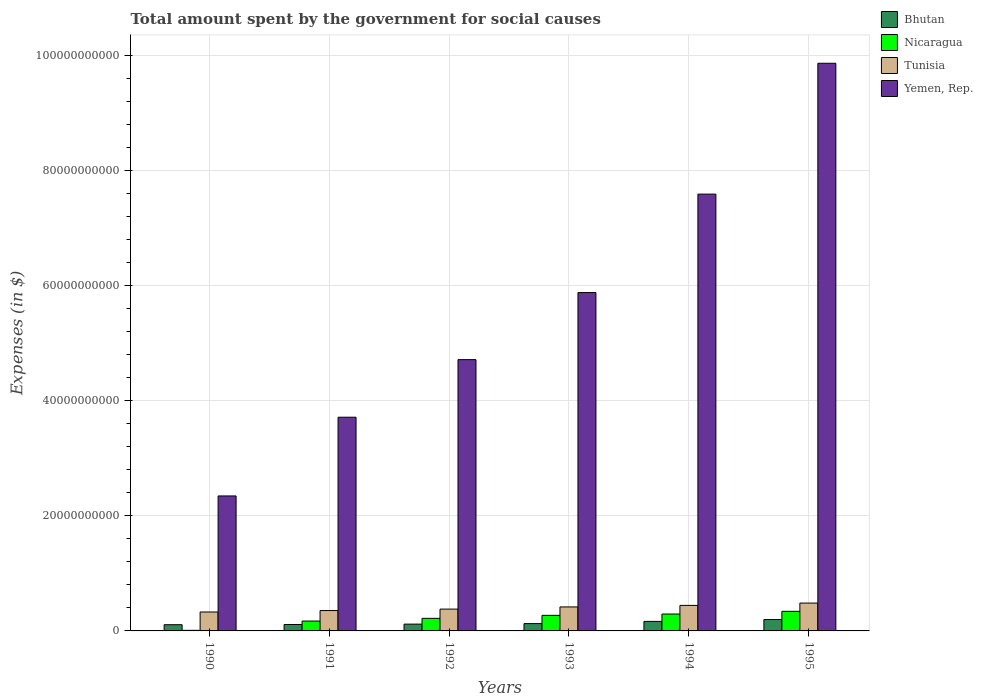How many different coloured bars are there?
Provide a short and direct response. 4. How many bars are there on the 6th tick from the left?
Offer a very short reply. 4. How many bars are there on the 5th tick from the right?
Offer a terse response. 4. What is the label of the 6th group of bars from the left?
Your answer should be compact. 1995. What is the amount spent for social causes by the government in Tunisia in 1995?
Provide a succinct answer. 4.84e+09. Across all years, what is the maximum amount spent for social causes by the government in Bhutan?
Offer a very short reply. 1.98e+09. Across all years, what is the minimum amount spent for social causes by the government in Nicaragua?
Offer a very short reply. 1.02e+08. In which year was the amount spent for social causes by the government in Nicaragua maximum?
Offer a terse response. 1995. What is the total amount spent for social causes by the government in Tunisia in the graph?
Provide a short and direct response. 2.41e+1. What is the difference between the amount spent for social causes by the government in Tunisia in 1993 and that in 1994?
Offer a very short reply. -2.65e+08. What is the difference between the amount spent for social causes by the government in Tunisia in 1995 and the amount spent for social causes by the government in Yemen, Rep. in 1990?
Keep it short and to the point. -1.86e+1. What is the average amount spent for social causes by the government in Tunisia per year?
Ensure brevity in your answer.  4.01e+09. In the year 1995, what is the difference between the amount spent for social causes by the government in Yemen, Rep. and amount spent for social causes by the government in Tunisia?
Your answer should be very brief. 9.38e+1. In how many years, is the amount spent for social causes by the government in Bhutan greater than 36000000000 $?
Make the answer very short. 0. What is the ratio of the amount spent for social causes by the government in Yemen, Rep. in 1992 to that in 1995?
Offer a very short reply. 0.48. Is the amount spent for social causes by the government in Nicaragua in 1992 less than that in 1994?
Keep it short and to the point. Yes. Is the difference between the amount spent for social causes by the government in Yemen, Rep. in 1993 and 1995 greater than the difference between the amount spent for social causes by the government in Tunisia in 1993 and 1995?
Provide a succinct answer. No. What is the difference between the highest and the second highest amount spent for social causes by the government in Bhutan?
Keep it short and to the point. 3.28e+08. What is the difference between the highest and the lowest amount spent for social causes by the government in Bhutan?
Give a very brief answer. 9.02e+08. Is the sum of the amount spent for social causes by the government in Yemen, Rep. in 1991 and 1994 greater than the maximum amount spent for social causes by the government in Nicaragua across all years?
Offer a terse response. Yes. Is it the case that in every year, the sum of the amount spent for social causes by the government in Nicaragua and amount spent for social causes by the government in Tunisia is greater than the sum of amount spent for social causes by the government in Bhutan and amount spent for social causes by the government in Yemen, Rep.?
Provide a short and direct response. No. What does the 1st bar from the left in 1991 represents?
Provide a succinct answer. Bhutan. What does the 3rd bar from the right in 1990 represents?
Offer a very short reply. Nicaragua. Does the graph contain any zero values?
Give a very brief answer. No. Where does the legend appear in the graph?
Ensure brevity in your answer.  Top right. How many legend labels are there?
Offer a very short reply. 4. How are the legend labels stacked?
Provide a succinct answer. Vertical. What is the title of the graph?
Your response must be concise. Total amount spent by the government for social causes. What is the label or title of the X-axis?
Offer a very short reply. Years. What is the label or title of the Y-axis?
Offer a very short reply. Expenses (in $). What is the Expenses (in $) in Bhutan in 1990?
Offer a terse response. 1.08e+09. What is the Expenses (in $) of Nicaragua in 1990?
Ensure brevity in your answer.  1.02e+08. What is the Expenses (in $) of Tunisia in 1990?
Your answer should be compact. 3.29e+09. What is the Expenses (in $) in Yemen, Rep. in 1990?
Offer a terse response. 2.35e+1. What is the Expenses (in $) in Bhutan in 1991?
Your answer should be very brief. 1.12e+09. What is the Expenses (in $) in Nicaragua in 1991?
Give a very brief answer. 1.71e+09. What is the Expenses (in $) of Tunisia in 1991?
Give a very brief answer. 3.54e+09. What is the Expenses (in $) in Yemen, Rep. in 1991?
Your answer should be very brief. 3.71e+1. What is the Expenses (in $) in Bhutan in 1992?
Provide a succinct answer. 1.18e+09. What is the Expenses (in $) of Nicaragua in 1992?
Provide a succinct answer. 2.19e+09. What is the Expenses (in $) of Tunisia in 1992?
Offer a very short reply. 3.79e+09. What is the Expenses (in $) of Yemen, Rep. in 1992?
Make the answer very short. 4.71e+1. What is the Expenses (in $) in Bhutan in 1993?
Give a very brief answer. 1.27e+09. What is the Expenses (in $) in Nicaragua in 1993?
Your answer should be compact. 2.71e+09. What is the Expenses (in $) in Tunisia in 1993?
Offer a very short reply. 4.17e+09. What is the Expenses (in $) in Yemen, Rep. in 1993?
Provide a succinct answer. 5.88e+1. What is the Expenses (in $) in Bhutan in 1994?
Your answer should be very brief. 1.65e+09. What is the Expenses (in $) in Nicaragua in 1994?
Give a very brief answer. 2.94e+09. What is the Expenses (in $) in Tunisia in 1994?
Give a very brief answer. 4.43e+09. What is the Expenses (in $) of Yemen, Rep. in 1994?
Offer a very short reply. 7.59e+1. What is the Expenses (in $) in Bhutan in 1995?
Give a very brief answer. 1.98e+09. What is the Expenses (in $) in Nicaragua in 1995?
Make the answer very short. 3.41e+09. What is the Expenses (in $) in Tunisia in 1995?
Your answer should be very brief. 4.84e+09. What is the Expenses (in $) of Yemen, Rep. in 1995?
Provide a succinct answer. 9.86e+1. Across all years, what is the maximum Expenses (in $) in Bhutan?
Make the answer very short. 1.98e+09. Across all years, what is the maximum Expenses (in $) in Nicaragua?
Keep it short and to the point. 3.41e+09. Across all years, what is the maximum Expenses (in $) in Tunisia?
Your answer should be very brief. 4.84e+09. Across all years, what is the maximum Expenses (in $) of Yemen, Rep.?
Your response must be concise. 9.86e+1. Across all years, what is the minimum Expenses (in $) of Bhutan?
Your answer should be compact. 1.08e+09. Across all years, what is the minimum Expenses (in $) of Nicaragua?
Keep it short and to the point. 1.02e+08. Across all years, what is the minimum Expenses (in $) in Tunisia?
Make the answer very short. 3.29e+09. Across all years, what is the minimum Expenses (in $) in Yemen, Rep.?
Provide a succinct answer. 2.35e+1. What is the total Expenses (in $) of Bhutan in the graph?
Provide a short and direct response. 8.29e+09. What is the total Expenses (in $) in Nicaragua in the graph?
Provide a short and direct response. 1.31e+1. What is the total Expenses (in $) in Tunisia in the graph?
Ensure brevity in your answer.  2.41e+1. What is the total Expenses (in $) of Yemen, Rep. in the graph?
Provide a succinct answer. 3.41e+11. What is the difference between the Expenses (in $) of Bhutan in 1990 and that in 1991?
Your response must be concise. -3.82e+07. What is the difference between the Expenses (in $) in Nicaragua in 1990 and that in 1991?
Your answer should be very brief. -1.61e+09. What is the difference between the Expenses (in $) of Tunisia in 1990 and that in 1991?
Make the answer very short. -2.52e+08. What is the difference between the Expenses (in $) of Yemen, Rep. in 1990 and that in 1991?
Ensure brevity in your answer.  -1.37e+1. What is the difference between the Expenses (in $) of Bhutan in 1990 and that in 1992?
Offer a terse response. -1.04e+08. What is the difference between the Expenses (in $) in Nicaragua in 1990 and that in 1992?
Your response must be concise. -2.09e+09. What is the difference between the Expenses (in $) in Tunisia in 1990 and that in 1992?
Your response must be concise. -5.01e+08. What is the difference between the Expenses (in $) of Yemen, Rep. in 1990 and that in 1992?
Provide a succinct answer. -2.37e+1. What is the difference between the Expenses (in $) of Bhutan in 1990 and that in 1993?
Make the answer very short. -1.93e+08. What is the difference between the Expenses (in $) of Nicaragua in 1990 and that in 1993?
Provide a succinct answer. -2.60e+09. What is the difference between the Expenses (in $) in Tunisia in 1990 and that in 1993?
Ensure brevity in your answer.  -8.80e+08. What is the difference between the Expenses (in $) in Yemen, Rep. in 1990 and that in 1993?
Ensure brevity in your answer.  -3.53e+1. What is the difference between the Expenses (in $) in Bhutan in 1990 and that in 1994?
Provide a succinct answer. -5.74e+08. What is the difference between the Expenses (in $) in Nicaragua in 1990 and that in 1994?
Give a very brief answer. -2.83e+09. What is the difference between the Expenses (in $) in Tunisia in 1990 and that in 1994?
Your response must be concise. -1.15e+09. What is the difference between the Expenses (in $) in Yemen, Rep. in 1990 and that in 1994?
Keep it short and to the point. -5.24e+1. What is the difference between the Expenses (in $) in Bhutan in 1990 and that in 1995?
Ensure brevity in your answer.  -9.02e+08. What is the difference between the Expenses (in $) of Nicaragua in 1990 and that in 1995?
Give a very brief answer. -3.30e+09. What is the difference between the Expenses (in $) of Tunisia in 1990 and that in 1995?
Provide a succinct answer. -1.55e+09. What is the difference between the Expenses (in $) of Yemen, Rep. in 1990 and that in 1995?
Offer a terse response. -7.52e+1. What is the difference between the Expenses (in $) of Bhutan in 1991 and that in 1992?
Offer a very short reply. -6.56e+07. What is the difference between the Expenses (in $) in Nicaragua in 1991 and that in 1992?
Your answer should be compact. -4.74e+08. What is the difference between the Expenses (in $) of Tunisia in 1991 and that in 1992?
Give a very brief answer. -2.49e+08. What is the difference between the Expenses (in $) in Yemen, Rep. in 1991 and that in 1992?
Ensure brevity in your answer.  -1.00e+1. What is the difference between the Expenses (in $) of Bhutan in 1991 and that in 1993?
Provide a short and direct response. -1.55e+08. What is the difference between the Expenses (in $) of Nicaragua in 1991 and that in 1993?
Make the answer very short. -9.92e+08. What is the difference between the Expenses (in $) in Tunisia in 1991 and that in 1993?
Offer a terse response. -6.28e+08. What is the difference between the Expenses (in $) in Yemen, Rep. in 1991 and that in 1993?
Make the answer very short. -2.17e+1. What is the difference between the Expenses (in $) in Bhutan in 1991 and that in 1994?
Provide a short and direct response. -5.36e+08. What is the difference between the Expenses (in $) of Nicaragua in 1991 and that in 1994?
Provide a succinct answer. -1.22e+09. What is the difference between the Expenses (in $) in Tunisia in 1991 and that in 1994?
Your response must be concise. -8.93e+08. What is the difference between the Expenses (in $) of Yemen, Rep. in 1991 and that in 1994?
Your answer should be very brief. -3.88e+1. What is the difference between the Expenses (in $) in Bhutan in 1991 and that in 1995?
Make the answer very short. -8.64e+08. What is the difference between the Expenses (in $) in Nicaragua in 1991 and that in 1995?
Give a very brief answer. -1.69e+09. What is the difference between the Expenses (in $) of Tunisia in 1991 and that in 1995?
Give a very brief answer. -1.30e+09. What is the difference between the Expenses (in $) in Yemen, Rep. in 1991 and that in 1995?
Offer a terse response. -6.15e+1. What is the difference between the Expenses (in $) of Bhutan in 1992 and that in 1993?
Give a very brief answer. -8.91e+07. What is the difference between the Expenses (in $) of Nicaragua in 1992 and that in 1993?
Offer a terse response. -5.19e+08. What is the difference between the Expenses (in $) in Tunisia in 1992 and that in 1993?
Provide a succinct answer. -3.79e+08. What is the difference between the Expenses (in $) of Yemen, Rep. in 1992 and that in 1993?
Ensure brevity in your answer.  -1.17e+1. What is the difference between the Expenses (in $) of Bhutan in 1992 and that in 1994?
Provide a succinct answer. -4.71e+08. What is the difference between the Expenses (in $) of Nicaragua in 1992 and that in 1994?
Give a very brief answer. -7.49e+08. What is the difference between the Expenses (in $) of Tunisia in 1992 and that in 1994?
Provide a succinct answer. -6.44e+08. What is the difference between the Expenses (in $) in Yemen, Rep. in 1992 and that in 1994?
Make the answer very short. -2.88e+1. What is the difference between the Expenses (in $) in Bhutan in 1992 and that in 1995?
Give a very brief answer. -7.98e+08. What is the difference between the Expenses (in $) in Nicaragua in 1992 and that in 1995?
Offer a very short reply. -1.22e+09. What is the difference between the Expenses (in $) in Tunisia in 1992 and that in 1995?
Your answer should be very brief. -1.05e+09. What is the difference between the Expenses (in $) of Yemen, Rep. in 1992 and that in 1995?
Offer a terse response. -5.15e+1. What is the difference between the Expenses (in $) in Bhutan in 1993 and that in 1994?
Give a very brief answer. -3.82e+08. What is the difference between the Expenses (in $) in Nicaragua in 1993 and that in 1994?
Provide a short and direct response. -2.30e+08. What is the difference between the Expenses (in $) in Tunisia in 1993 and that in 1994?
Ensure brevity in your answer.  -2.65e+08. What is the difference between the Expenses (in $) in Yemen, Rep. in 1993 and that in 1994?
Offer a very short reply. -1.71e+1. What is the difference between the Expenses (in $) in Bhutan in 1993 and that in 1995?
Your answer should be very brief. -7.09e+08. What is the difference between the Expenses (in $) in Nicaragua in 1993 and that in 1995?
Make the answer very short. -6.99e+08. What is the difference between the Expenses (in $) in Tunisia in 1993 and that in 1995?
Give a very brief answer. -6.69e+08. What is the difference between the Expenses (in $) of Yemen, Rep. in 1993 and that in 1995?
Your response must be concise. -3.98e+1. What is the difference between the Expenses (in $) of Bhutan in 1994 and that in 1995?
Provide a succinct answer. -3.28e+08. What is the difference between the Expenses (in $) in Nicaragua in 1994 and that in 1995?
Provide a short and direct response. -4.69e+08. What is the difference between the Expenses (in $) of Tunisia in 1994 and that in 1995?
Provide a succinct answer. -4.04e+08. What is the difference between the Expenses (in $) of Yemen, Rep. in 1994 and that in 1995?
Offer a terse response. -2.27e+1. What is the difference between the Expenses (in $) in Bhutan in 1990 and the Expenses (in $) in Nicaragua in 1991?
Give a very brief answer. -6.34e+08. What is the difference between the Expenses (in $) of Bhutan in 1990 and the Expenses (in $) of Tunisia in 1991?
Your answer should be compact. -2.46e+09. What is the difference between the Expenses (in $) of Bhutan in 1990 and the Expenses (in $) of Yemen, Rep. in 1991?
Ensure brevity in your answer.  -3.61e+1. What is the difference between the Expenses (in $) in Nicaragua in 1990 and the Expenses (in $) in Tunisia in 1991?
Ensure brevity in your answer.  -3.44e+09. What is the difference between the Expenses (in $) of Nicaragua in 1990 and the Expenses (in $) of Yemen, Rep. in 1991?
Make the answer very short. -3.70e+1. What is the difference between the Expenses (in $) of Tunisia in 1990 and the Expenses (in $) of Yemen, Rep. in 1991?
Your answer should be very brief. -3.38e+1. What is the difference between the Expenses (in $) in Bhutan in 1990 and the Expenses (in $) in Nicaragua in 1992?
Offer a terse response. -1.11e+09. What is the difference between the Expenses (in $) of Bhutan in 1990 and the Expenses (in $) of Tunisia in 1992?
Keep it short and to the point. -2.71e+09. What is the difference between the Expenses (in $) of Bhutan in 1990 and the Expenses (in $) of Yemen, Rep. in 1992?
Provide a succinct answer. -4.61e+1. What is the difference between the Expenses (in $) in Nicaragua in 1990 and the Expenses (in $) in Tunisia in 1992?
Provide a succinct answer. -3.69e+09. What is the difference between the Expenses (in $) in Nicaragua in 1990 and the Expenses (in $) in Yemen, Rep. in 1992?
Provide a short and direct response. -4.70e+1. What is the difference between the Expenses (in $) in Tunisia in 1990 and the Expenses (in $) in Yemen, Rep. in 1992?
Give a very brief answer. -4.38e+1. What is the difference between the Expenses (in $) in Bhutan in 1990 and the Expenses (in $) in Nicaragua in 1993?
Ensure brevity in your answer.  -1.63e+09. What is the difference between the Expenses (in $) in Bhutan in 1990 and the Expenses (in $) in Tunisia in 1993?
Your answer should be very brief. -3.09e+09. What is the difference between the Expenses (in $) in Bhutan in 1990 and the Expenses (in $) in Yemen, Rep. in 1993?
Give a very brief answer. -5.77e+1. What is the difference between the Expenses (in $) in Nicaragua in 1990 and the Expenses (in $) in Tunisia in 1993?
Your response must be concise. -4.07e+09. What is the difference between the Expenses (in $) in Nicaragua in 1990 and the Expenses (in $) in Yemen, Rep. in 1993?
Offer a very short reply. -5.87e+1. What is the difference between the Expenses (in $) in Tunisia in 1990 and the Expenses (in $) in Yemen, Rep. in 1993?
Provide a succinct answer. -5.55e+1. What is the difference between the Expenses (in $) in Bhutan in 1990 and the Expenses (in $) in Nicaragua in 1994?
Offer a very short reply. -1.86e+09. What is the difference between the Expenses (in $) of Bhutan in 1990 and the Expenses (in $) of Tunisia in 1994?
Your answer should be compact. -3.36e+09. What is the difference between the Expenses (in $) of Bhutan in 1990 and the Expenses (in $) of Yemen, Rep. in 1994?
Offer a very short reply. -7.48e+1. What is the difference between the Expenses (in $) in Nicaragua in 1990 and the Expenses (in $) in Tunisia in 1994?
Your answer should be very brief. -4.33e+09. What is the difference between the Expenses (in $) of Nicaragua in 1990 and the Expenses (in $) of Yemen, Rep. in 1994?
Your answer should be compact. -7.58e+1. What is the difference between the Expenses (in $) of Tunisia in 1990 and the Expenses (in $) of Yemen, Rep. in 1994?
Offer a very short reply. -7.26e+1. What is the difference between the Expenses (in $) in Bhutan in 1990 and the Expenses (in $) in Nicaragua in 1995?
Provide a short and direct response. -2.33e+09. What is the difference between the Expenses (in $) in Bhutan in 1990 and the Expenses (in $) in Tunisia in 1995?
Your response must be concise. -3.76e+09. What is the difference between the Expenses (in $) of Bhutan in 1990 and the Expenses (in $) of Yemen, Rep. in 1995?
Provide a succinct answer. -9.76e+1. What is the difference between the Expenses (in $) in Nicaragua in 1990 and the Expenses (in $) in Tunisia in 1995?
Offer a terse response. -4.74e+09. What is the difference between the Expenses (in $) in Nicaragua in 1990 and the Expenses (in $) in Yemen, Rep. in 1995?
Your answer should be very brief. -9.85e+1. What is the difference between the Expenses (in $) of Tunisia in 1990 and the Expenses (in $) of Yemen, Rep. in 1995?
Ensure brevity in your answer.  -9.53e+1. What is the difference between the Expenses (in $) in Bhutan in 1991 and the Expenses (in $) in Nicaragua in 1992?
Your answer should be very brief. -1.07e+09. What is the difference between the Expenses (in $) in Bhutan in 1991 and the Expenses (in $) in Tunisia in 1992?
Your answer should be very brief. -2.67e+09. What is the difference between the Expenses (in $) in Bhutan in 1991 and the Expenses (in $) in Yemen, Rep. in 1992?
Offer a terse response. -4.60e+1. What is the difference between the Expenses (in $) of Nicaragua in 1991 and the Expenses (in $) of Tunisia in 1992?
Your answer should be very brief. -2.08e+09. What is the difference between the Expenses (in $) of Nicaragua in 1991 and the Expenses (in $) of Yemen, Rep. in 1992?
Your answer should be compact. -4.54e+1. What is the difference between the Expenses (in $) of Tunisia in 1991 and the Expenses (in $) of Yemen, Rep. in 1992?
Your answer should be very brief. -4.36e+1. What is the difference between the Expenses (in $) in Bhutan in 1991 and the Expenses (in $) in Nicaragua in 1993?
Offer a very short reply. -1.59e+09. What is the difference between the Expenses (in $) in Bhutan in 1991 and the Expenses (in $) in Tunisia in 1993?
Offer a very short reply. -3.05e+09. What is the difference between the Expenses (in $) in Bhutan in 1991 and the Expenses (in $) in Yemen, Rep. in 1993?
Make the answer very short. -5.77e+1. What is the difference between the Expenses (in $) in Nicaragua in 1991 and the Expenses (in $) in Tunisia in 1993?
Make the answer very short. -2.46e+09. What is the difference between the Expenses (in $) in Nicaragua in 1991 and the Expenses (in $) in Yemen, Rep. in 1993?
Give a very brief answer. -5.71e+1. What is the difference between the Expenses (in $) of Tunisia in 1991 and the Expenses (in $) of Yemen, Rep. in 1993?
Ensure brevity in your answer.  -5.53e+1. What is the difference between the Expenses (in $) in Bhutan in 1991 and the Expenses (in $) in Nicaragua in 1994?
Your answer should be compact. -1.82e+09. What is the difference between the Expenses (in $) of Bhutan in 1991 and the Expenses (in $) of Tunisia in 1994?
Your answer should be compact. -3.32e+09. What is the difference between the Expenses (in $) in Bhutan in 1991 and the Expenses (in $) in Yemen, Rep. in 1994?
Your answer should be very brief. -7.48e+1. What is the difference between the Expenses (in $) in Nicaragua in 1991 and the Expenses (in $) in Tunisia in 1994?
Keep it short and to the point. -2.72e+09. What is the difference between the Expenses (in $) of Nicaragua in 1991 and the Expenses (in $) of Yemen, Rep. in 1994?
Your response must be concise. -7.42e+1. What is the difference between the Expenses (in $) of Tunisia in 1991 and the Expenses (in $) of Yemen, Rep. in 1994?
Give a very brief answer. -7.24e+1. What is the difference between the Expenses (in $) of Bhutan in 1991 and the Expenses (in $) of Nicaragua in 1995?
Offer a very short reply. -2.29e+09. What is the difference between the Expenses (in $) of Bhutan in 1991 and the Expenses (in $) of Tunisia in 1995?
Offer a very short reply. -3.72e+09. What is the difference between the Expenses (in $) of Bhutan in 1991 and the Expenses (in $) of Yemen, Rep. in 1995?
Offer a terse response. -9.75e+1. What is the difference between the Expenses (in $) in Nicaragua in 1991 and the Expenses (in $) in Tunisia in 1995?
Offer a very short reply. -3.12e+09. What is the difference between the Expenses (in $) in Nicaragua in 1991 and the Expenses (in $) in Yemen, Rep. in 1995?
Make the answer very short. -9.69e+1. What is the difference between the Expenses (in $) of Tunisia in 1991 and the Expenses (in $) of Yemen, Rep. in 1995?
Offer a terse response. -9.51e+1. What is the difference between the Expenses (in $) of Bhutan in 1992 and the Expenses (in $) of Nicaragua in 1993?
Offer a terse response. -1.52e+09. What is the difference between the Expenses (in $) in Bhutan in 1992 and the Expenses (in $) in Tunisia in 1993?
Provide a succinct answer. -2.99e+09. What is the difference between the Expenses (in $) of Bhutan in 1992 and the Expenses (in $) of Yemen, Rep. in 1993?
Make the answer very short. -5.76e+1. What is the difference between the Expenses (in $) of Nicaragua in 1992 and the Expenses (in $) of Tunisia in 1993?
Ensure brevity in your answer.  -1.98e+09. What is the difference between the Expenses (in $) in Nicaragua in 1992 and the Expenses (in $) in Yemen, Rep. in 1993?
Provide a succinct answer. -5.66e+1. What is the difference between the Expenses (in $) in Tunisia in 1992 and the Expenses (in $) in Yemen, Rep. in 1993?
Offer a very short reply. -5.50e+1. What is the difference between the Expenses (in $) in Bhutan in 1992 and the Expenses (in $) in Nicaragua in 1994?
Offer a very short reply. -1.75e+09. What is the difference between the Expenses (in $) of Bhutan in 1992 and the Expenses (in $) of Tunisia in 1994?
Provide a short and direct response. -3.25e+09. What is the difference between the Expenses (in $) in Bhutan in 1992 and the Expenses (in $) in Yemen, Rep. in 1994?
Your answer should be very brief. -7.47e+1. What is the difference between the Expenses (in $) in Nicaragua in 1992 and the Expenses (in $) in Tunisia in 1994?
Provide a succinct answer. -2.25e+09. What is the difference between the Expenses (in $) in Nicaragua in 1992 and the Expenses (in $) in Yemen, Rep. in 1994?
Your answer should be very brief. -7.37e+1. What is the difference between the Expenses (in $) of Tunisia in 1992 and the Expenses (in $) of Yemen, Rep. in 1994?
Your answer should be very brief. -7.21e+1. What is the difference between the Expenses (in $) in Bhutan in 1992 and the Expenses (in $) in Nicaragua in 1995?
Your answer should be compact. -2.22e+09. What is the difference between the Expenses (in $) of Bhutan in 1992 and the Expenses (in $) of Tunisia in 1995?
Your answer should be compact. -3.66e+09. What is the difference between the Expenses (in $) in Bhutan in 1992 and the Expenses (in $) in Yemen, Rep. in 1995?
Your answer should be compact. -9.75e+1. What is the difference between the Expenses (in $) of Nicaragua in 1992 and the Expenses (in $) of Tunisia in 1995?
Offer a terse response. -2.65e+09. What is the difference between the Expenses (in $) in Nicaragua in 1992 and the Expenses (in $) in Yemen, Rep. in 1995?
Ensure brevity in your answer.  -9.64e+1. What is the difference between the Expenses (in $) in Tunisia in 1992 and the Expenses (in $) in Yemen, Rep. in 1995?
Provide a succinct answer. -9.48e+1. What is the difference between the Expenses (in $) of Bhutan in 1993 and the Expenses (in $) of Nicaragua in 1994?
Provide a succinct answer. -1.66e+09. What is the difference between the Expenses (in $) of Bhutan in 1993 and the Expenses (in $) of Tunisia in 1994?
Offer a terse response. -3.16e+09. What is the difference between the Expenses (in $) in Bhutan in 1993 and the Expenses (in $) in Yemen, Rep. in 1994?
Give a very brief answer. -7.46e+1. What is the difference between the Expenses (in $) in Nicaragua in 1993 and the Expenses (in $) in Tunisia in 1994?
Provide a short and direct response. -1.73e+09. What is the difference between the Expenses (in $) in Nicaragua in 1993 and the Expenses (in $) in Yemen, Rep. in 1994?
Offer a terse response. -7.32e+1. What is the difference between the Expenses (in $) in Tunisia in 1993 and the Expenses (in $) in Yemen, Rep. in 1994?
Give a very brief answer. -7.17e+1. What is the difference between the Expenses (in $) of Bhutan in 1993 and the Expenses (in $) of Nicaragua in 1995?
Your answer should be compact. -2.13e+09. What is the difference between the Expenses (in $) in Bhutan in 1993 and the Expenses (in $) in Tunisia in 1995?
Your response must be concise. -3.57e+09. What is the difference between the Expenses (in $) of Bhutan in 1993 and the Expenses (in $) of Yemen, Rep. in 1995?
Your response must be concise. -9.74e+1. What is the difference between the Expenses (in $) in Nicaragua in 1993 and the Expenses (in $) in Tunisia in 1995?
Give a very brief answer. -2.13e+09. What is the difference between the Expenses (in $) in Nicaragua in 1993 and the Expenses (in $) in Yemen, Rep. in 1995?
Provide a short and direct response. -9.59e+1. What is the difference between the Expenses (in $) in Tunisia in 1993 and the Expenses (in $) in Yemen, Rep. in 1995?
Offer a terse response. -9.45e+1. What is the difference between the Expenses (in $) of Bhutan in 1994 and the Expenses (in $) of Nicaragua in 1995?
Ensure brevity in your answer.  -1.75e+09. What is the difference between the Expenses (in $) in Bhutan in 1994 and the Expenses (in $) in Tunisia in 1995?
Your answer should be very brief. -3.18e+09. What is the difference between the Expenses (in $) of Bhutan in 1994 and the Expenses (in $) of Yemen, Rep. in 1995?
Offer a terse response. -9.70e+1. What is the difference between the Expenses (in $) in Nicaragua in 1994 and the Expenses (in $) in Tunisia in 1995?
Ensure brevity in your answer.  -1.90e+09. What is the difference between the Expenses (in $) in Nicaragua in 1994 and the Expenses (in $) in Yemen, Rep. in 1995?
Offer a very short reply. -9.57e+1. What is the difference between the Expenses (in $) of Tunisia in 1994 and the Expenses (in $) of Yemen, Rep. in 1995?
Provide a succinct answer. -9.42e+1. What is the average Expenses (in $) of Bhutan per year?
Provide a succinct answer. 1.38e+09. What is the average Expenses (in $) in Nicaragua per year?
Provide a succinct answer. 2.18e+09. What is the average Expenses (in $) in Tunisia per year?
Your answer should be very brief. 4.01e+09. What is the average Expenses (in $) in Yemen, Rep. per year?
Your answer should be very brief. 5.68e+1. In the year 1990, what is the difference between the Expenses (in $) of Bhutan and Expenses (in $) of Nicaragua?
Keep it short and to the point. 9.77e+08. In the year 1990, what is the difference between the Expenses (in $) in Bhutan and Expenses (in $) in Tunisia?
Ensure brevity in your answer.  -2.21e+09. In the year 1990, what is the difference between the Expenses (in $) in Bhutan and Expenses (in $) in Yemen, Rep.?
Provide a short and direct response. -2.24e+1. In the year 1990, what is the difference between the Expenses (in $) in Nicaragua and Expenses (in $) in Tunisia?
Your answer should be very brief. -3.19e+09. In the year 1990, what is the difference between the Expenses (in $) of Nicaragua and Expenses (in $) of Yemen, Rep.?
Offer a very short reply. -2.34e+1. In the year 1990, what is the difference between the Expenses (in $) of Tunisia and Expenses (in $) of Yemen, Rep.?
Make the answer very short. -2.02e+1. In the year 1991, what is the difference between the Expenses (in $) of Bhutan and Expenses (in $) of Nicaragua?
Your answer should be very brief. -5.96e+08. In the year 1991, what is the difference between the Expenses (in $) of Bhutan and Expenses (in $) of Tunisia?
Your answer should be compact. -2.42e+09. In the year 1991, what is the difference between the Expenses (in $) of Bhutan and Expenses (in $) of Yemen, Rep.?
Offer a terse response. -3.60e+1. In the year 1991, what is the difference between the Expenses (in $) of Nicaragua and Expenses (in $) of Tunisia?
Provide a succinct answer. -1.83e+09. In the year 1991, what is the difference between the Expenses (in $) in Nicaragua and Expenses (in $) in Yemen, Rep.?
Offer a terse response. -3.54e+1. In the year 1991, what is the difference between the Expenses (in $) in Tunisia and Expenses (in $) in Yemen, Rep.?
Ensure brevity in your answer.  -3.36e+1. In the year 1992, what is the difference between the Expenses (in $) of Bhutan and Expenses (in $) of Nicaragua?
Give a very brief answer. -1.00e+09. In the year 1992, what is the difference between the Expenses (in $) in Bhutan and Expenses (in $) in Tunisia?
Make the answer very short. -2.61e+09. In the year 1992, what is the difference between the Expenses (in $) in Bhutan and Expenses (in $) in Yemen, Rep.?
Keep it short and to the point. -4.60e+1. In the year 1992, what is the difference between the Expenses (in $) of Nicaragua and Expenses (in $) of Tunisia?
Provide a succinct answer. -1.60e+09. In the year 1992, what is the difference between the Expenses (in $) in Nicaragua and Expenses (in $) in Yemen, Rep.?
Your answer should be very brief. -4.49e+1. In the year 1992, what is the difference between the Expenses (in $) in Tunisia and Expenses (in $) in Yemen, Rep.?
Ensure brevity in your answer.  -4.33e+1. In the year 1993, what is the difference between the Expenses (in $) in Bhutan and Expenses (in $) in Nicaragua?
Give a very brief answer. -1.43e+09. In the year 1993, what is the difference between the Expenses (in $) of Bhutan and Expenses (in $) of Tunisia?
Your answer should be compact. -2.90e+09. In the year 1993, what is the difference between the Expenses (in $) of Bhutan and Expenses (in $) of Yemen, Rep.?
Offer a terse response. -5.75e+1. In the year 1993, what is the difference between the Expenses (in $) of Nicaragua and Expenses (in $) of Tunisia?
Keep it short and to the point. -1.46e+09. In the year 1993, what is the difference between the Expenses (in $) of Nicaragua and Expenses (in $) of Yemen, Rep.?
Make the answer very short. -5.61e+1. In the year 1993, what is the difference between the Expenses (in $) of Tunisia and Expenses (in $) of Yemen, Rep.?
Keep it short and to the point. -5.46e+1. In the year 1994, what is the difference between the Expenses (in $) of Bhutan and Expenses (in $) of Nicaragua?
Make the answer very short. -1.28e+09. In the year 1994, what is the difference between the Expenses (in $) of Bhutan and Expenses (in $) of Tunisia?
Provide a short and direct response. -2.78e+09. In the year 1994, what is the difference between the Expenses (in $) in Bhutan and Expenses (in $) in Yemen, Rep.?
Offer a very short reply. -7.42e+1. In the year 1994, what is the difference between the Expenses (in $) of Nicaragua and Expenses (in $) of Tunisia?
Provide a short and direct response. -1.50e+09. In the year 1994, what is the difference between the Expenses (in $) in Nicaragua and Expenses (in $) in Yemen, Rep.?
Make the answer very short. -7.30e+1. In the year 1994, what is the difference between the Expenses (in $) of Tunisia and Expenses (in $) of Yemen, Rep.?
Your answer should be compact. -7.15e+1. In the year 1995, what is the difference between the Expenses (in $) in Bhutan and Expenses (in $) in Nicaragua?
Offer a terse response. -1.42e+09. In the year 1995, what is the difference between the Expenses (in $) in Bhutan and Expenses (in $) in Tunisia?
Your answer should be compact. -2.86e+09. In the year 1995, what is the difference between the Expenses (in $) of Bhutan and Expenses (in $) of Yemen, Rep.?
Keep it short and to the point. -9.67e+1. In the year 1995, what is the difference between the Expenses (in $) of Nicaragua and Expenses (in $) of Tunisia?
Make the answer very short. -1.43e+09. In the year 1995, what is the difference between the Expenses (in $) of Nicaragua and Expenses (in $) of Yemen, Rep.?
Make the answer very short. -9.52e+1. In the year 1995, what is the difference between the Expenses (in $) of Tunisia and Expenses (in $) of Yemen, Rep.?
Your answer should be very brief. -9.38e+1. What is the ratio of the Expenses (in $) of Bhutan in 1990 to that in 1991?
Your response must be concise. 0.97. What is the ratio of the Expenses (in $) in Nicaragua in 1990 to that in 1991?
Keep it short and to the point. 0.06. What is the ratio of the Expenses (in $) in Tunisia in 1990 to that in 1991?
Offer a terse response. 0.93. What is the ratio of the Expenses (in $) of Yemen, Rep. in 1990 to that in 1991?
Your response must be concise. 0.63. What is the ratio of the Expenses (in $) of Bhutan in 1990 to that in 1992?
Keep it short and to the point. 0.91. What is the ratio of the Expenses (in $) in Nicaragua in 1990 to that in 1992?
Keep it short and to the point. 0.05. What is the ratio of the Expenses (in $) of Tunisia in 1990 to that in 1992?
Ensure brevity in your answer.  0.87. What is the ratio of the Expenses (in $) of Yemen, Rep. in 1990 to that in 1992?
Give a very brief answer. 0.5. What is the ratio of the Expenses (in $) in Bhutan in 1990 to that in 1993?
Keep it short and to the point. 0.85. What is the ratio of the Expenses (in $) of Nicaragua in 1990 to that in 1993?
Give a very brief answer. 0.04. What is the ratio of the Expenses (in $) in Tunisia in 1990 to that in 1993?
Your answer should be very brief. 0.79. What is the ratio of the Expenses (in $) of Yemen, Rep. in 1990 to that in 1993?
Give a very brief answer. 0.4. What is the ratio of the Expenses (in $) of Bhutan in 1990 to that in 1994?
Make the answer very short. 0.65. What is the ratio of the Expenses (in $) of Nicaragua in 1990 to that in 1994?
Provide a succinct answer. 0.03. What is the ratio of the Expenses (in $) of Tunisia in 1990 to that in 1994?
Ensure brevity in your answer.  0.74. What is the ratio of the Expenses (in $) in Yemen, Rep. in 1990 to that in 1994?
Your answer should be compact. 0.31. What is the ratio of the Expenses (in $) of Bhutan in 1990 to that in 1995?
Your answer should be very brief. 0.54. What is the ratio of the Expenses (in $) in Nicaragua in 1990 to that in 1995?
Offer a very short reply. 0.03. What is the ratio of the Expenses (in $) of Tunisia in 1990 to that in 1995?
Make the answer very short. 0.68. What is the ratio of the Expenses (in $) in Yemen, Rep. in 1990 to that in 1995?
Keep it short and to the point. 0.24. What is the ratio of the Expenses (in $) of Bhutan in 1991 to that in 1992?
Ensure brevity in your answer.  0.94. What is the ratio of the Expenses (in $) of Nicaragua in 1991 to that in 1992?
Your response must be concise. 0.78. What is the ratio of the Expenses (in $) of Tunisia in 1991 to that in 1992?
Offer a very short reply. 0.93. What is the ratio of the Expenses (in $) in Yemen, Rep. in 1991 to that in 1992?
Make the answer very short. 0.79. What is the ratio of the Expenses (in $) in Bhutan in 1991 to that in 1993?
Provide a succinct answer. 0.88. What is the ratio of the Expenses (in $) in Nicaragua in 1991 to that in 1993?
Provide a succinct answer. 0.63. What is the ratio of the Expenses (in $) of Tunisia in 1991 to that in 1993?
Your response must be concise. 0.85. What is the ratio of the Expenses (in $) of Yemen, Rep. in 1991 to that in 1993?
Your answer should be very brief. 0.63. What is the ratio of the Expenses (in $) in Bhutan in 1991 to that in 1994?
Your answer should be compact. 0.68. What is the ratio of the Expenses (in $) of Nicaragua in 1991 to that in 1994?
Ensure brevity in your answer.  0.58. What is the ratio of the Expenses (in $) of Tunisia in 1991 to that in 1994?
Offer a terse response. 0.8. What is the ratio of the Expenses (in $) of Yemen, Rep. in 1991 to that in 1994?
Provide a succinct answer. 0.49. What is the ratio of the Expenses (in $) of Bhutan in 1991 to that in 1995?
Give a very brief answer. 0.56. What is the ratio of the Expenses (in $) of Nicaragua in 1991 to that in 1995?
Your answer should be compact. 0.5. What is the ratio of the Expenses (in $) of Tunisia in 1991 to that in 1995?
Ensure brevity in your answer.  0.73. What is the ratio of the Expenses (in $) in Yemen, Rep. in 1991 to that in 1995?
Offer a terse response. 0.38. What is the ratio of the Expenses (in $) in Nicaragua in 1992 to that in 1993?
Offer a very short reply. 0.81. What is the ratio of the Expenses (in $) of Yemen, Rep. in 1992 to that in 1993?
Your answer should be compact. 0.8. What is the ratio of the Expenses (in $) of Bhutan in 1992 to that in 1994?
Your response must be concise. 0.72. What is the ratio of the Expenses (in $) in Nicaragua in 1992 to that in 1994?
Keep it short and to the point. 0.74. What is the ratio of the Expenses (in $) in Tunisia in 1992 to that in 1994?
Give a very brief answer. 0.85. What is the ratio of the Expenses (in $) in Yemen, Rep. in 1992 to that in 1994?
Offer a very short reply. 0.62. What is the ratio of the Expenses (in $) in Bhutan in 1992 to that in 1995?
Your answer should be compact. 0.6. What is the ratio of the Expenses (in $) of Nicaragua in 1992 to that in 1995?
Keep it short and to the point. 0.64. What is the ratio of the Expenses (in $) in Tunisia in 1992 to that in 1995?
Offer a very short reply. 0.78. What is the ratio of the Expenses (in $) of Yemen, Rep. in 1992 to that in 1995?
Your answer should be compact. 0.48. What is the ratio of the Expenses (in $) of Bhutan in 1993 to that in 1994?
Provide a succinct answer. 0.77. What is the ratio of the Expenses (in $) of Nicaragua in 1993 to that in 1994?
Your answer should be very brief. 0.92. What is the ratio of the Expenses (in $) of Tunisia in 1993 to that in 1994?
Keep it short and to the point. 0.94. What is the ratio of the Expenses (in $) in Yemen, Rep. in 1993 to that in 1994?
Keep it short and to the point. 0.77. What is the ratio of the Expenses (in $) of Bhutan in 1993 to that in 1995?
Your response must be concise. 0.64. What is the ratio of the Expenses (in $) in Nicaragua in 1993 to that in 1995?
Your response must be concise. 0.79. What is the ratio of the Expenses (in $) in Tunisia in 1993 to that in 1995?
Ensure brevity in your answer.  0.86. What is the ratio of the Expenses (in $) in Yemen, Rep. in 1993 to that in 1995?
Your response must be concise. 0.6. What is the ratio of the Expenses (in $) in Bhutan in 1994 to that in 1995?
Offer a very short reply. 0.83. What is the ratio of the Expenses (in $) of Nicaragua in 1994 to that in 1995?
Provide a succinct answer. 0.86. What is the ratio of the Expenses (in $) in Tunisia in 1994 to that in 1995?
Your answer should be very brief. 0.92. What is the ratio of the Expenses (in $) in Yemen, Rep. in 1994 to that in 1995?
Offer a terse response. 0.77. What is the difference between the highest and the second highest Expenses (in $) of Bhutan?
Make the answer very short. 3.28e+08. What is the difference between the highest and the second highest Expenses (in $) in Nicaragua?
Keep it short and to the point. 4.69e+08. What is the difference between the highest and the second highest Expenses (in $) of Tunisia?
Provide a succinct answer. 4.04e+08. What is the difference between the highest and the second highest Expenses (in $) in Yemen, Rep.?
Your response must be concise. 2.27e+1. What is the difference between the highest and the lowest Expenses (in $) of Bhutan?
Keep it short and to the point. 9.02e+08. What is the difference between the highest and the lowest Expenses (in $) of Nicaragua?
Give a very brief answer. 3.30e+09. What is the difference between the highest and the lowest Expenses (in $) in Tunisia?
Give a very brief answer. 1.55e+09. What is the difference between the highest and the lowest Expenses (in $) of Yemen, Rep.?
Your answer should be compact. 7.52e+1. 